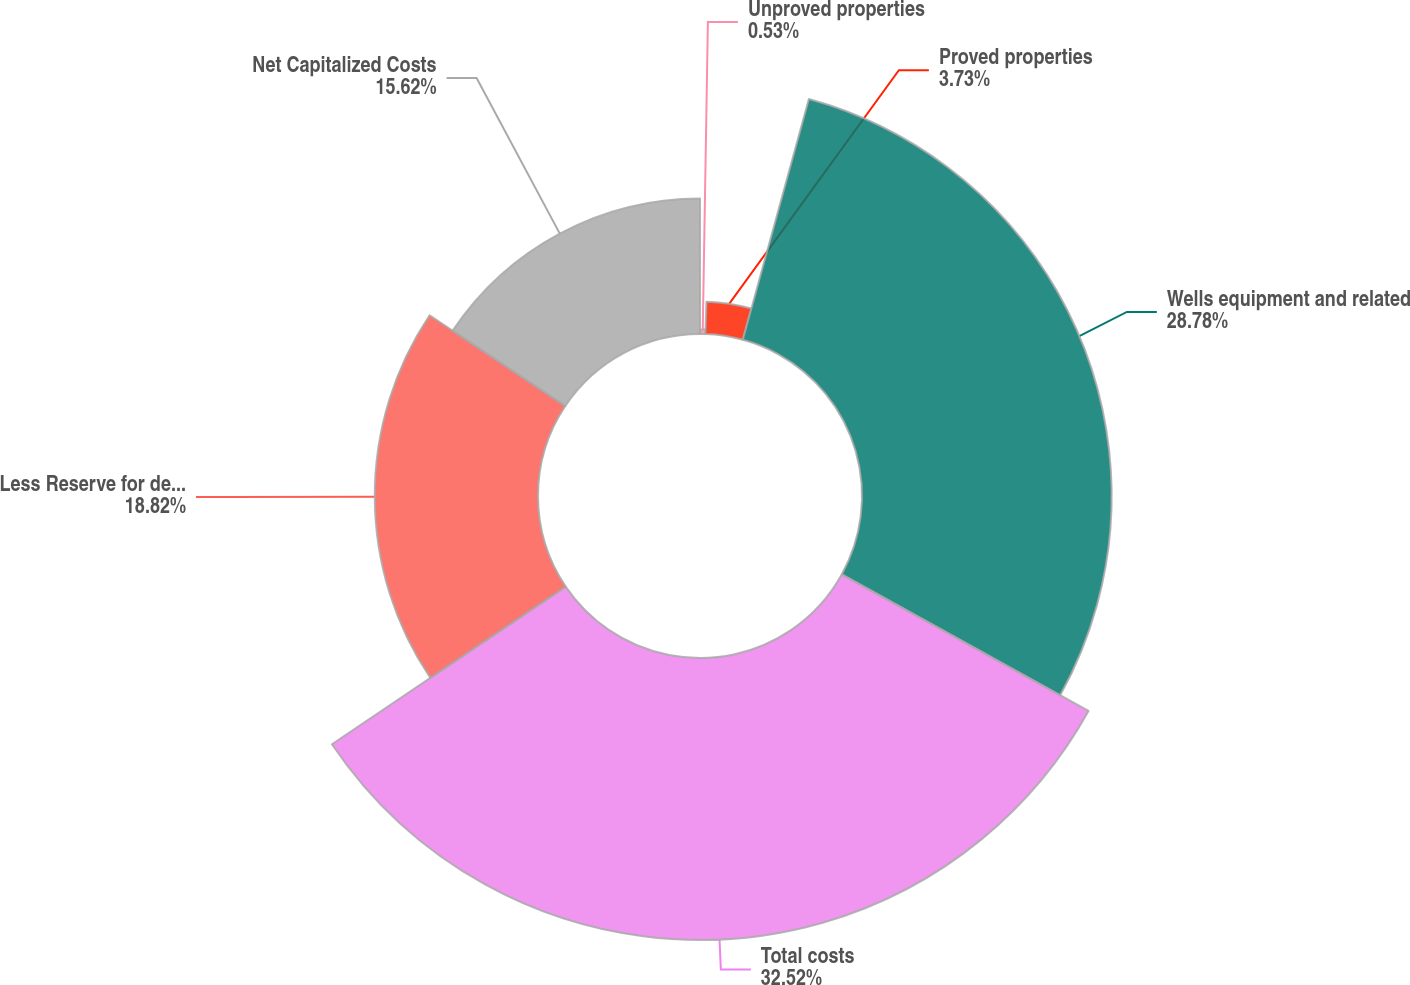Convert chart to OTSL. <chart><loc_0><loc_0><loc_500><loc_500><pie_chart><fcel>Unproved properties<fcel>Proved properties<fcel>Wells equipment and related<fcel>Total costs<fcel>Less Reserve for depreciation<fcel>Net Capitalized Costs<nl><fcel>0.53%<fcel>3.73%<fcel>28.78%<fcel>32.51%<fcel>18.82%<fcel>15.62%<nl></chart> 